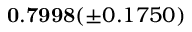<formula> <loc_0><loc_0><loc_500><loc_500>0 . 7 9 9 8 ( \pm 0 . 1 7 5 0 )</formula> 